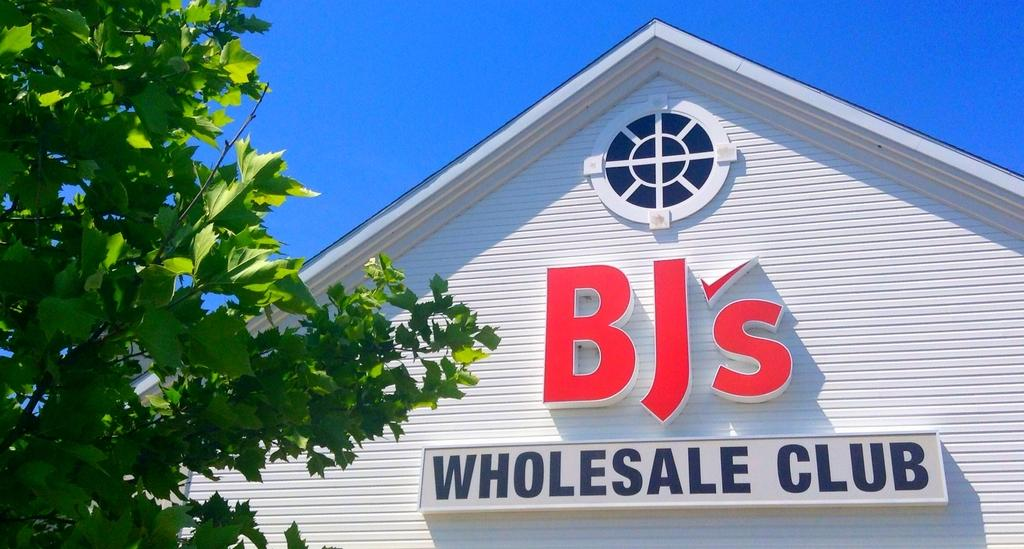<image>
Give a short and clear explanation of the subsequent image. The sign on the side of the building identifies it as a wholesale club. 